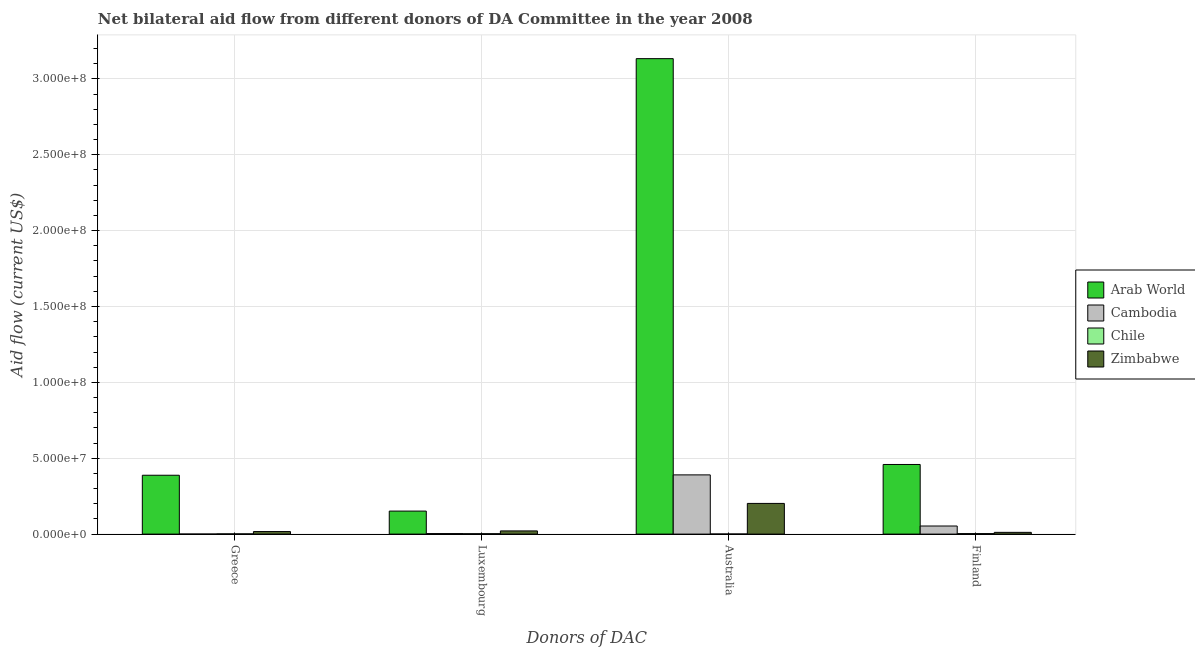How many different coloured bars are there?
Provide a succinct answer. 4. How many groups of bars are there?
Offer a very short reply. 4. Are the number of bars on each tick of the X-axis equal?
Provide a short and direct response. Yes. How many bars are there on the 1st tick from the left?
Your response must be concise. 4. What is the amount of aid given by australia in Arab World?
Offer a very short reply. 3.13e+08. Across all countries, what is the maximum amount of aid given by australia?
Your answer should be compact. 3.13e+08. Across all countries, what is the minimum amount of aid given by australia?
Give a very brief answer. 7.00e+04. In which country was the amount of aid given by australia maximum?
Offer a very short reply. Arab World. In which country was the amount of aid given by greece minimum?
Provide a succinct answer. Cambodia. What is the total amount of aid given by finland in the graph?
Your answer should be compact. 5.27e+07. What is the difference between the amount of aid given by luxembourg in Zimbabwe and that in Arab World?
Give a very brief answer. -1.31e+07. What is the difference between the amount of aid given by finland in Chile and the amount of aid given by australia in Cambodia?
Provide a short and direct response. -3.87e+07. What is the average amount of aid given by finland per country?
Make the answer very short. 1.32e+07. What is the difference between the amount of aid given by finland and amount of aid given by luxembourg in Arab World?
Keep it short and to the point. 3.07e+07. In how many countries, is the amount of aid given by luxembourg greater than 30000000 US$?
Offer a very short reply. 0. What is the ratio of the amount of aid given by luxembourg in Arab World to that in Cambodia?
Keep it short and to the point. 44.62. Is the difference between the amount of aid given by luxembourg in Cambodia and Zimbabwe greater than the difference between the amount of aid given by australia in Cambodia and Zimbabwe?
Your answer should be compact. No. What is the difference between the highest and the second highest amount of aid given by luxembourg?
Ensure brevity in your answer.  1.31e+07. What is the difference between the highest and the lowest amount of aid given by australia?
Ensure brevity in your answer.  3.13e+08. In how many countries, is the amount of aid given by greece greater than the average amount of aid given by greece taken over all countries?
Your answer should be compact. 1. Is the sum of the amount of aid given by finland in Zimbabwe and Arab World greater than the maximum amount of aid given by australia across all countries?
Your answer should be very brief. No. Is it the case that in every country, the sum of the amount of aid given by greece and amount of aid given by australia is greater than the sum of amount of aid given by finland and amount of aid given by luxembourg?
Ensure brevity in your answer.  No. What does the 1st bar from the left in Luxembourg represents?
Your answer should be compact. Arab World. What does the 4th bar from the right in Greece represents?
Provide a succinct answer. Arab World. Is it the case that in every country, the sum of the amount of aid given by greece and amount of aid given by luxembourg is greater than the amount of aid given by australia?
Offer a terse response. No. How many bars are there?
Offer a very short reply. 16. How many countries are there in the graph?
Your response must be concise. 4. Does the graph contain any zero values?
Your answer should be compact. No. What is the title of the graph?
Your response must be concise. Net bilateral aid flow from different donors of DA Committee in the year 2008. What is the label or title of the X-axis?
Provide a succinct answer. Donors of DAC. What is the label or title of the Y-axis?
Give a very brief answer. Aid flow (current US$). What is the Aid flow (current US$) in Arab World in Greece?
Make the answer very short. 3.88e+07. What is the Aid flow (current US$) of Cambodia in Greece?
Keep it short and to the point. 3.00e+04. What is the Aid flow (current US$) of Chile in Greece?
Your answer should be compact. 1.60e+05. What is the Aid flow (current US$) of Zimbabwe in Greece?
Offer a terse response. 1.68e+06. What is the Aid flow (current US$) of Arab World in Luxembourg?
Ensure brevity in your answer.  1.52e+07. What is the Aid flow (current US$) of Zimbabwe in Luxembourg?
Ensure brevity in your answer.  2.10e+06. What is the Aid flow (current US$) in Arab World in Australia?
Provide a succinct answer. 3.13e+08. What is the Aid flow (current US$) of Cambodia in Australia?
Make the answer very short. 3.90e+07. What is the Aid flow (current US$) of Zimbabwe in Australia?
Make the answer very short. 2.02e+07. What is the Aid flow (current US$) of Arab World in Finland?
Offer a very short reply. 4.59e+07. What is the Aid flow (current US$) of Cambodia in Finland?
Provide a short and direct response. 5.33e+06. What is the Aid flow (current US$) of Zimbabwe in Finland?
Make the answer very short. 1.15e+06. Across all Donors of DAC, what is the maximum Aid flow (current US$) of Arab World?
Provide a short and direct response. 3.13e+08. Across all Donors of DAC, what is the maximum Aid flow (current US$) of Cambodia?
Your response must be concise. 3.90e+07. Across all Donors of DAC, what is the maximum Aid flow (current US$) of Zimbabwe?
Your response must be concise. 2.02e+07. Across all Donors of DAC, what is the minimum Aid flow (current US$) of Arab World?
Offer a terse response. 1.52e+07. Across all Donors of DAC, what is the minimum Aid flow (current US$) of Chile?
Ensure brevity in your answer.  7.00e+04. Across all Donors of DAC, what is the minimum Aid flow (current US$) of Zimbabwe?
Give a very brief answer. 1.15e+06. What is the total Aid flow (current US$) of Arab World in the graph?
Your response must be concise. 4.13e+08. What is the total Aid flow (current US$) of Cambodia in the graph?
Offer a very short reply. 4.47e+07. What is the total Aid flow (current US$) of Chile in the graph?
Your answer should be very brief. 8.30e+05. What is the total Aid flow (current US$) in Zimbabwe in the graph?
Provide a succinct answer. 2.52e+07. What is the difference between the Aid flow (current US$) in Arab World in Greece and that in Luxembourg?
Provide a succinct answer. 2.36e+07. What is the difference between the Aid flow (current US$) in Cambodia in Greece and that in Luxembourg?
Offer a very short reply. -3.10e+05. What is the difference between the Aid flow (current US$) in Zimbabwe in Greece and that in Luxembourg?
Offer a very short reply. -4.20e+05. What is the difference between the Aid flow (current US$) of Arab World in Greece and that in Australia?
Give a very brief answer. -2.75e+08. What is the difference between the Aid flow (current US$) of Cambodia in Greece and that in Australia?
Provide a short and direct response. -3.90e+07. What is the difference between the Aid flow (current US$) in Chile in Greece and that in Australia?
Offer a very short reply. 9.00e+04. What is the difference between the Aid flow (current US$) in Zimbabwe in Greece and that in Australia?
Your response must be concise. -1.85e+07. What is the difference between the Aid flow (current US$) of Arab World in Greece and that in Finland?
Provide a short and direct response. -7.10e+06. What is the difference between the Aid flow (current US$) of Cambodia in Greece and that in Finland?
Your answer should be very brief. -5.30e+06. What is the difference between the Aid flow (current US$) in Zimbabwe in Greece and that in Finland?
Your response must be concise. 5.30e+05. What is the difference between the Aid flow (current US$) of Arab World in Luxembourg and that in Australia?
Keep it short and to the point. -2.98e+08. What is the difference between the Aid flow (current US$) of Cambodia in Luxembourg and that in Australia?
Keep it short and to the point. -3.87e+07. What is the difference between the Aid flow (current US$) in Chile in Luxembourg and that in Australia?
Offer a terse response. 2.00e+05. What is the difference between the Aid flow (current US$) in Zimbabwe in Luxembourg and that in Australia?
Your answer should be very brief. -1.81e+07. What is the difference between the Aid flow (current US$) in Arab World in Luxembourg and that in Finland?
Your response must be concise. -3.07e+07. What is the difference between the Aid flow (current US$) of Cambodia in Luxembourg and that in Finland?
Your answer should be very brief. -4.99e+06. What is the difference between the Aid flow (current US$) in Chile in Luxembourg and that in Finland?
Your answer should be compact. -6.00e+04. What is the difference between the Aid flow (current US$) in Zimbabwe in Luxembourg and that in Finland?
Your response must be concise. 9.50e+05. What is the difference between the Aid flow (current US$) in Arab World in Australia and that in Finland?
Make the answer very short. 2.67e+08. What is the difference between the Aid flow (current US$) in Cambodia in Australia and that in Finland?
Your response must be concise. 3.37e+07. What is the difference between the Aid flow (current US$) of Zimbabwe in Australia and that in Finland?
Give a very brief answer. 1.91e+07. What is the difference between the Aid flow (current US$) in Arab World in Greece and the Aid flow (current US$) in Cambodia in Luxembourg?
Make the answer very short. 3.84e+07. What is the difference between the Aid flow (current US$) in Arab World in Greece and the Aid flow (current US$) in Chile in Luxembourg?
Give a very brief answer. 3.85e+07. What is the difference between the Aid flow (current US$) of Arab World in Greece and the Aid flow (current US$) of Zimbabwe in Luxembourg?
Give a very brief answer. 3.67e+07. What is the difference between the Aid flow (current US$) in Cambodia in Greece and the Aid flow (current US$) in Chile in Luxembourg?
Provide a succinct answer. -2.40e+05. What is the difference between the Aid flow (current US$) of Cambodia in Greece and the Aid flow (current US$) of Zimbabwe in Luxembourg?
Your answer should be compact. -2.07e+06. What is the difference between the Aid flow (current US$) of Chile in Greece and the Aid flow (current US$) of Zimbabwe in Luxembourg?
Offer a very short reply. -1.94e+06. What is the difference between the Aid flow (current US$) in Arab World in Greece and the Aid flow (current US$) in Cambodia in Australia?
Offer a very short reply. -2.40e+05. What is the difference between the Aid flow (current US$) of Arab World in Greece and the Aid flow (current US$) of Chile in Australia?
Your response must be concise. 3.87e+07. What is the difference between the Aid flow (current US$) in Arab World in Greece and the Aid flow (current US$) in Zimbabwe in Australia?
Provide a succinct answer. 1.86e+07. What is the difference between the Aid flow (current US$) in Cambodia in Greece and the Aid flow (current US$) in Zimbabwe in Australia?
Provide a succinct answer. -2.02e+07. What is the difference between the Aid flow (current US$) of Chile in Greece and the Aid flow (current US$) of Zimbabwe in Australia?
Your response must be concise. -2.01e+07. What is the difference between the Aid flow (current US$) in Arab World in Greece and the Aid flow (current US$) in Cambodia in Finland?
Your response must be concise. 3.35e+07. What is the difference between the Aid flow (current US$) in Arab World in Greece and the Aid flow (current US$) in Chile in Finland?
Provide a short and direct response. 3.85e+07. What is the difference between the Aid flow (current US$) in Arab World in Greece and the Aid flow (current US$) in Zimbabwe in Finland?
Your answer should be compact. 3.76e+07. What is the difference between the Aid flow (current US$) of Cambodia in Greece and the Aid flow (current US$) of Chile in Finland?
Ensure brevity in your answer.  -3.00e+05. What is the difference between the Aid flow (current US$) of Cambodia in Greece and the Aid flow (current US$) of Zimbabwe in Finland?
Offer a terse response. -1.12e+06. What is the difference between the Aid flow (current US$) in Chile in Greece and the Aid flow (current US$) in Zimbabwe in Finland?
Ensure brevity in your answer.  -9.90e+05. What is the difference between the Aid flow (current US$) in Arab World in Luxembourg and the Aid flow (current US$) in Cambodia in Australia?
Your answer should be very brief. -2.39e+07. What is the difference between the Aid flow (current US$) in Arab World in Luxembourg and the Aid flow (current US$) in Chile in Australia?
Provide a short and direct response. 1.51e+07. What is the difference between the Aid flow (current US$) of Arab World in Luxembourg and the Aid flow (current US$) of Zimbabwe in Australia?
Provide a succinct answer. -5.05e+06. What is the difference between the Aid flow (current US$) of Cambodia in Luxembourg and the Aid flow (current US$) of Chile in Australia?
Ensure brevity in your answer.  2.70e+05. What is the difference between the Aid flow (current US$) in Cambodia in Luxembourg and the Aid flow (current US$) in Zimbabwe in Australia?
Offer a terse response. -1.99e+07. What is the difference between the Aid flow (current US$) in Chile in Luxembourg and the Aid flow (current US$) in Zimbabwe in Australia?
Your answer should be compact. -2.00e+07. What is the difference between the Aid flow (current US$) in Arab World in Luxembourg and the Aid flow (current US$) in Cambodia in Finland?
Make the answer very short. 9.84e+06. What is the difference between the Aid flow (current US$) of Arab World in Luxembourg and the Aid flow (current US$) of Chile in Finland?
Offer a very short reply. 1.48e+07. What is the difference between the Aid flow (current US$) of Arab World in Luxembourg and the Aid flow (current US$) of Zimbabwe in Finland?
Provide a succinct answer. 1.40e+07. What is the difference between the Aid flow (current US$) in Cambodia in Luxembourg and the Aid flow (current US$) in Chile in Finland?
Keep it short and to the point. 10000. What is the difference between the Aid flow (current US$) in Cambodia in Luxembourg and the Aid flow (current US$) in Zimbabwe in Finland?
Provide a succinct answer. -8.10e+05. What is the difference between the Aid flow (current US$) in Chile in Luxembourg and the Aid flow (current US$) in Zimbabwe in Finland?
Your response must be concise. -8.80e+05. What is the difference between the Aid flow (current US$) of Arab World in Australia and the Aid flow (current US$) of Cambodia in Finland?
Keep it short and to the point. 3.08e+08. What is the difference between the Aid flow (current US$) of Arab World in Australia and the Aid flow (current US$) of Chile in Finland?
Provide a succinct answer. 3.13e+08. What is the difference between the Aid flow (current US$) of Arab World in Australia and the Aid flow (current US$) of Zimbabwe in Finland?
Provide a succinct answer. 3.12e+08. What is the difference between the Aid flow (current US$) of Cambodia in Australia and the Aid flow (current US$) of Chile in Finland?
Provide a succinct answer. 3.87e+07. What is the difference between the Aid flow (current US$) in Cambodia in Australia and the Aid flow (current US$) in Zimbabwe in Finland?
Provide a short and direct response. 3.79e+07. What is the difference between the Aid flow (current US$) of Chile in Australia and the Aid flow (current US$) of Zimbabwe in Finland?
Provide a succinct answer. -1.08e+06. What is the average Aid flow (current US$) of Arab World per Donors of DAC?
Offer a very short reply. 1.03e+08. What is the average Aid flow (current US$) of Cambodia per Donors of DAC?
Keep it short and to the point. 1.12e+07. What is the average Aid flow (current US$) of Chile per Donors of DAC?
Give a very brief answer. 2.08e+05. What is the average Aid flow (current US$) of Zimbabwe per Donors of DAC?
Provide a succinct answer. 6.29e+06. What is the difference between the Aid flow (current US$) in Arab World and Aid flow (current US$) in Cambodia in Greece?
Make the answer very short. 3.88e+07. What is the difference between the Aid flow (current US$) in Arab World and Aid flow (current US$) in Chile in Greece?
Offer a terse response. 3.86e+07. What is the difference between the Aid flow (current US$) in Arab World and Aid flow (current US$) in Zimbabwe in Greece?
Offer a very short reply. 3.71e+07. What is the difference between the Aid flow (current US$) of Cambodia and Aid flow (current US$) of Chile in Greece?
Keep it short and to the point. -1.30e+05. What is the difference between the Aid flow (current US$) of Cambodia and Aid flow (current US$) of Zimbabwe in Greece?
Your response must be concise. -1.65e+06. What is the difference between the Aid flow (current US$) of Chile and Aid flow (current US$) of Zimbabwe in Greece?
Give a very brief answer. -1.52e+06. What is the difference between the Aid flow (current US$) of Arab World and Aid flow (current US$) of Cambodia in Luxembourg?
Keep it short and to the point. 1.48e+07. What is the difference between the Aid flow (current US$) of Arab World and Aid flow (current US$) of Chile in Luxembourg?
Ensure brevity in your answer.  1.49e+07. What is the difference between the Aid flow (current US$) of Arab World and Aid flow (current US$) of Zimbabwe in Luxembourg?
Make the answer very short. 1.31e+07. What is the difference between the Aid flow (current US$) of Cambodia and Aid flow (current US$) of Chile in Luxembourg?
Offer a very short reply. 7.00e+04. What is the difference between the Aid flow (current US$) in Cambodia and Aid flow (current US$) in Zimbabwe in Luxembourg?
Your answer should be compact. -1.76e+06. What is the difference between the Aid flow (current US$) in Chile and Aid flow (current US$) in Zimbabwe in Luxembourg?
Provide a short and direct response. -1.83e+06. What is the difference between the Aid flow (current US$) in Arab World and Aid flow (current US$) in Cambodia in Australia?
Offer a very short reply. 2.74e+08. What is the difference between the Aid flow (current US$) of Arab World and Aid flow (current US$) of Chile in Australia?
Make the answer very short. 3.13e+08. What is the difference between the Aid flow (current US$) of Arab World and Aid flow (current US$) of Zimbabwe in Australia?
Give a very brief answer. 2.93e+08. What is the difference between the Aid flow (current US$) of Cambodia and Aid flow (current US$) of Chile in Australia?
Offer a terse response. 3.90e+07. What is the difference between the Aid flow (current US$) in Cambodia and Aid flow (current US$) in Zimbabwe in Australia?
Your answer should be compact. 1.88e+07. What is the difference between the Aid flow (current US$) of Chile and Aid flow (current US$) of Zimbabwe in Australia?
Your response must be concise. -2.02e+07. What is the difference between the Aid flow (current US$) in Arab World and Aid flow (current US$) in Cambodia in Finland?
Your response must be concise. 4.06e+07. What is the difference between the Aid flow (current US$) in Arab World and Aid flow (current US$) in Chile in Finland?
Your response must be concise. 4.56e+07. What is the difference between the Aid flow (current US$) in Arab World and Aid flow (current US$) in Zimbabwe in Finland?
Your answer should be very brief. 4.47e+07. What is the difference between the Aid flow (current US$) in Cambodia and Aid flow (current US$) in Zimbabwe in Finland?
Offer a very short reply. 4.18e+06. What is the difference between the Aid flow (current US$) of Chile and Aid flow (current US$) of Zimbabwe in Finland?
Provide a short and direct response. -8.20e+05. What is the ratio of the Aid flow (current US$) in Arab World in Greece to that in Luxembourg?
Provide a succinct answer. 2.56. What is the ratio of the Aid flow (current US$) in Cambodia in Greece to that in Luxembourg?
Provide a succinct answer. 0.09. What is the ratio of the Aid flow (current US$) of Chile in Greece to that in Luxembourg?
Offer a very short reply. 0.59. What is the ratio of the Aid flow (current US$) of Arab World in Greece to that in Australia?
Your answer should be very brief. 0.12. What is the ratio of the Aid flow (current US$) in Cambodia in Greece to that in Australia?
Make the answer very short. 0. What is the ratio of the Aid flow (current US$) of Chile in Greece to that in Australia?
Keep it short and to the point. 2.29. What is the ratio of the Aid flow (current US$) of Zimbabwe in Greece to that in Australia?
Ensure brevity in your answer.  0.08. What is the ratio of the Aid flow (current US$) in Arab World in Greece to that in Finland?
Your answer should be very brief. 0.85. What is the ratio of the Aid flow (current US$) of Cambodia in Greece to that in Finland?
Offer a terse response. 0.01. What is the ratio of the Aid flow (current US$) of Chile in Greece to that in Finland?
Make the answer very short. 0.48. What is the ratio of the Aid flow (current US$) in Zimbabwe in Greece to that in Finland?
Keep it short and to the point. 1.46. What is the ratio of the Aid flow (current US$) of Arab World in Luxembourg to that in Australia?
Make the answer very short. 0.05. What is the ratio of the Aid flow (current US$) in Cambodia in Luxembourg to that in Australia?
Give a very brief answer. 0.01. What is the ratio of the Aid flow (current US$) of Chile in Luxembourg to that in Australia?
Your answer should be compact. 3.86. What is the ratio of the Aid flow (current US$) in Zimbabwe in Luxembourg to that in Australia?
Provide a succinct answer. 0.1. What is the ratio of the Aid flow (current US$) of Arab World in Luxembourg to that in Finland?
Keep it short and to the point. 0.33. What is the ratio of the Aid flow (current US$) in Cambodia in Luxembourg to that in Finland?
Provide a succinct answer. 0.06. What is the ratio of the Aid flow (current US$) of Chile in Luxembourg to that in Finland?
Give a very brief answer. 0.82. What is the ratio of the Aid flow (current US$) in Zimbabwe in Luxembourg to that in Finland?
Offer a terse response. 1.83. What is the ratio of the Aid flow (current US$) in Arab World in Australia to that in Finland?
Provide a succinct answer. 6.83. What is the ratio of the Aid flow (current US$) of Cambodia in Australia to that in Finland?
Provide a short and direct response. 7.32. What is the ratio of the Aid flow (current US$) of Chile in Australia to that in Finland?
Offer a terse response. 0.21. What is the ratio of the Aid flow (current US$) in Zimbabwe in Australia to that in Finland?
Ensure brevity in your answer.  17.58. What is the difference between the highest and the second highest Aid flow (current US$) in Arab World?
Ensure brevity in your answer.  2.67e+08. What is the difference between the highest and the second highest Aid flow (current US$) of Cambodia?
Keep it short and to the point. 3.37e+07. What is the difference between the highest and the second highest Aid flow (current US$) in Chile?
Offer a terse response. 6.00e+04. What is the difference between the highest and the second highest Aid flow (current US$) of Zimbabwe?
Ensure brevity in your answer.  1.81e+07. What is the difference between the highest and the lowest Aid flow (current US$) of Arab World?
Offer a very short reply. 2.98e+08. What is the difference between the highest and the lowest Aid flow (current US$) of Cambodia?
Give a very brief answer. 3.90e+07. What is the difference between the highest and the lowest Aid flow (current US$) in Zimbabwe?
Your answer should be compact. 1.91e+07. 